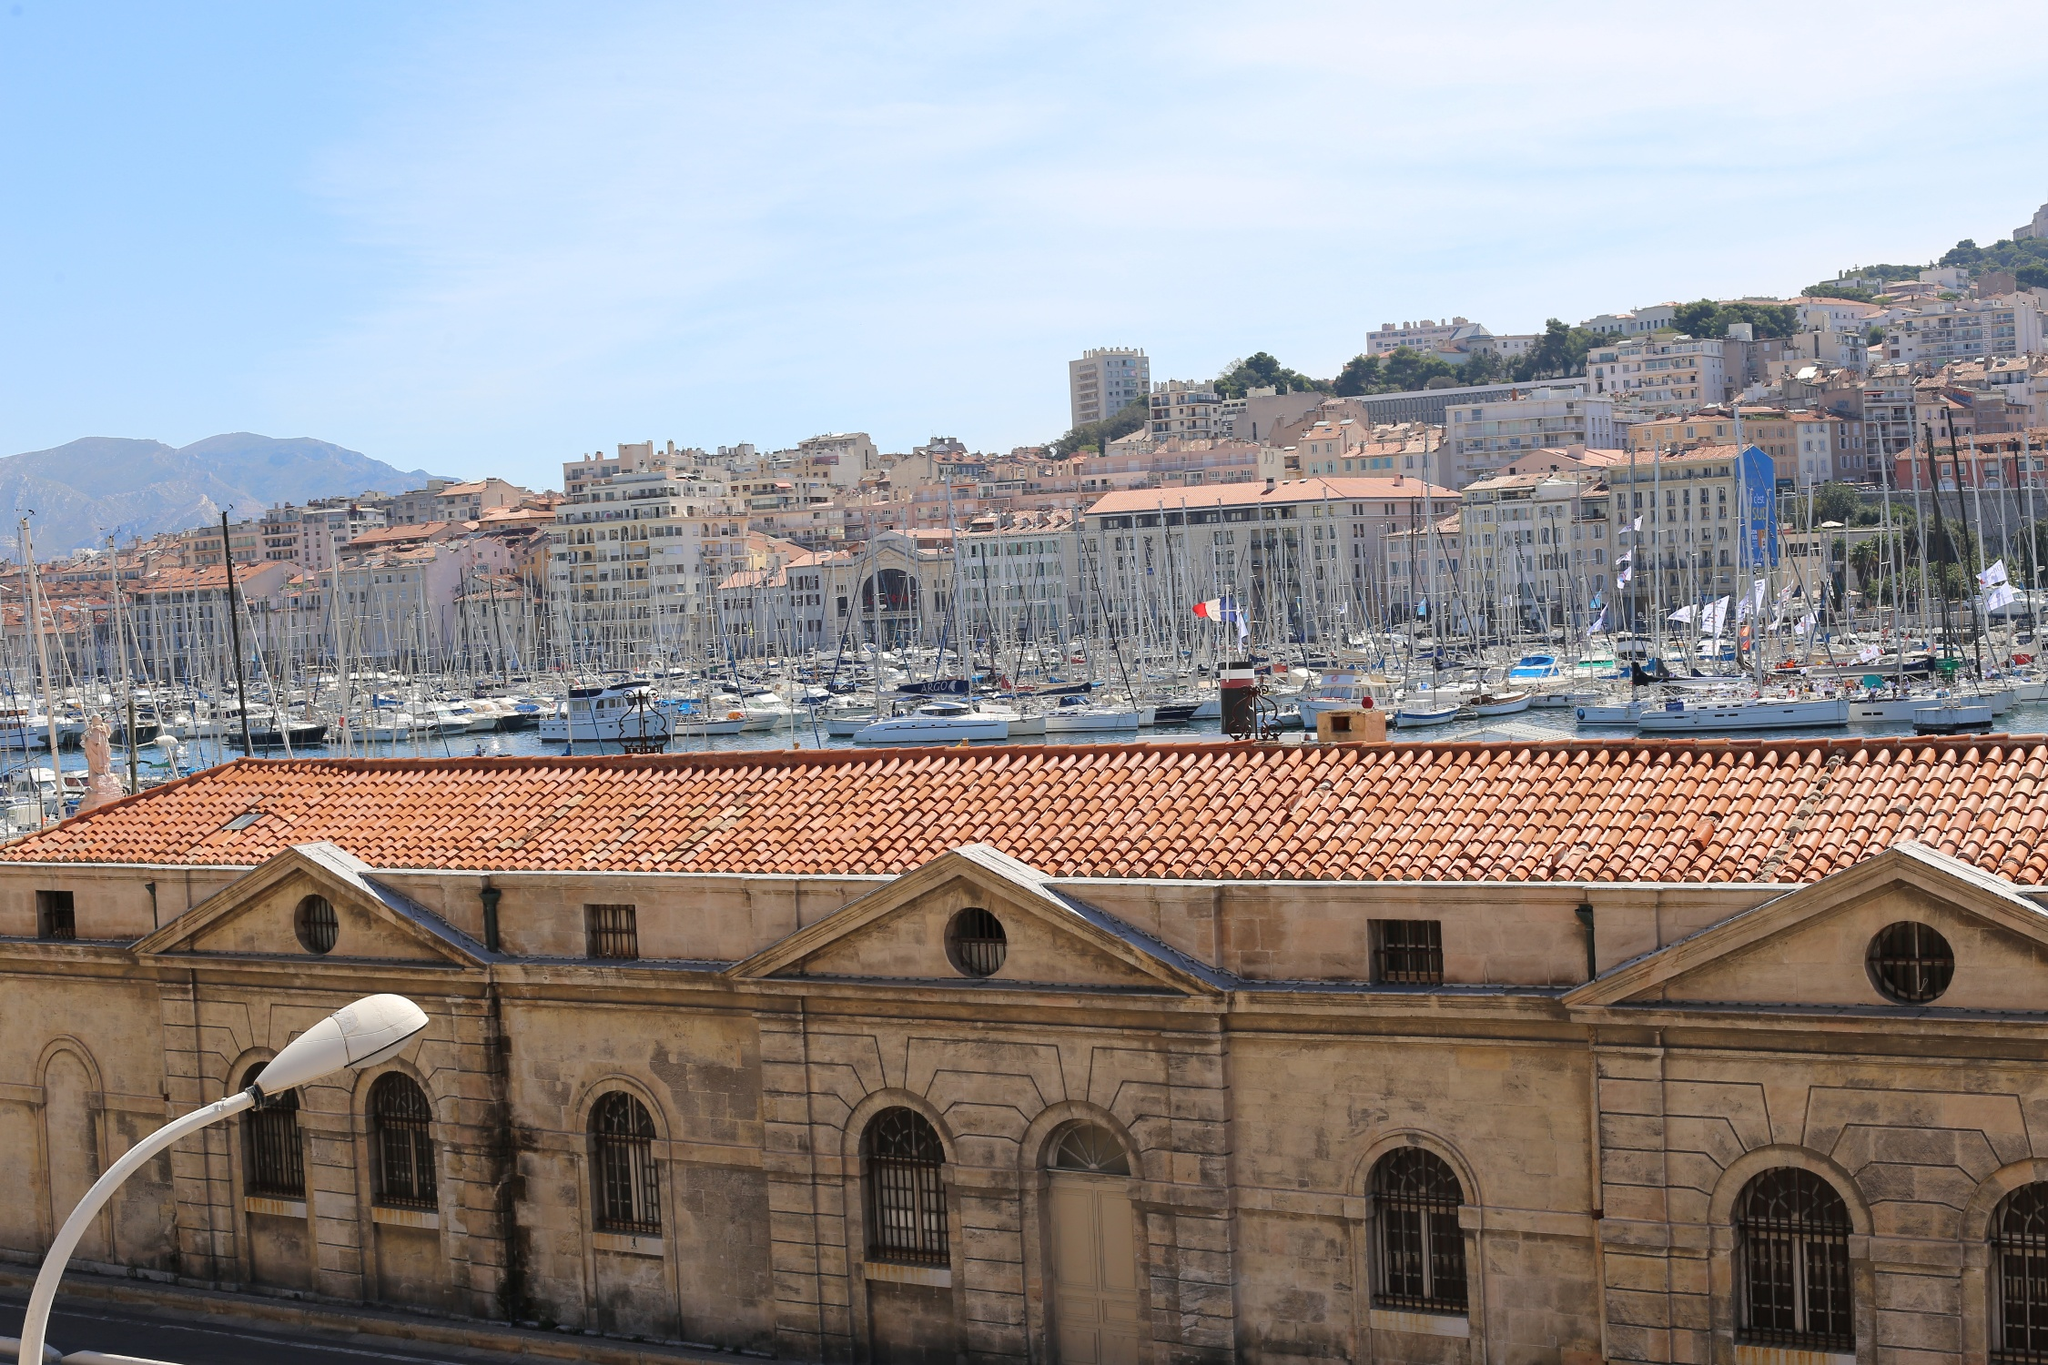What are the key elements in this picture? The image beautifully captures the Old Port of Marseille in France. The photograph, taken from a high vantage point, offers a panoramic view of the marina bustling with numerous boats and yachts. The water in the port showcases a stunning blue-green hue, blending harmoniously with the clear blue sky. The foreground features a historic building with a characteristic terracotta-tiled roof, and beyond the port, Marseille's cityscape rises with Mediterranean-style architecture in soft, warm colors. The Marseille Cathedral's grandeur can be faintly observed in the backdrop, adding a historic charm to an already vibrant scene. 